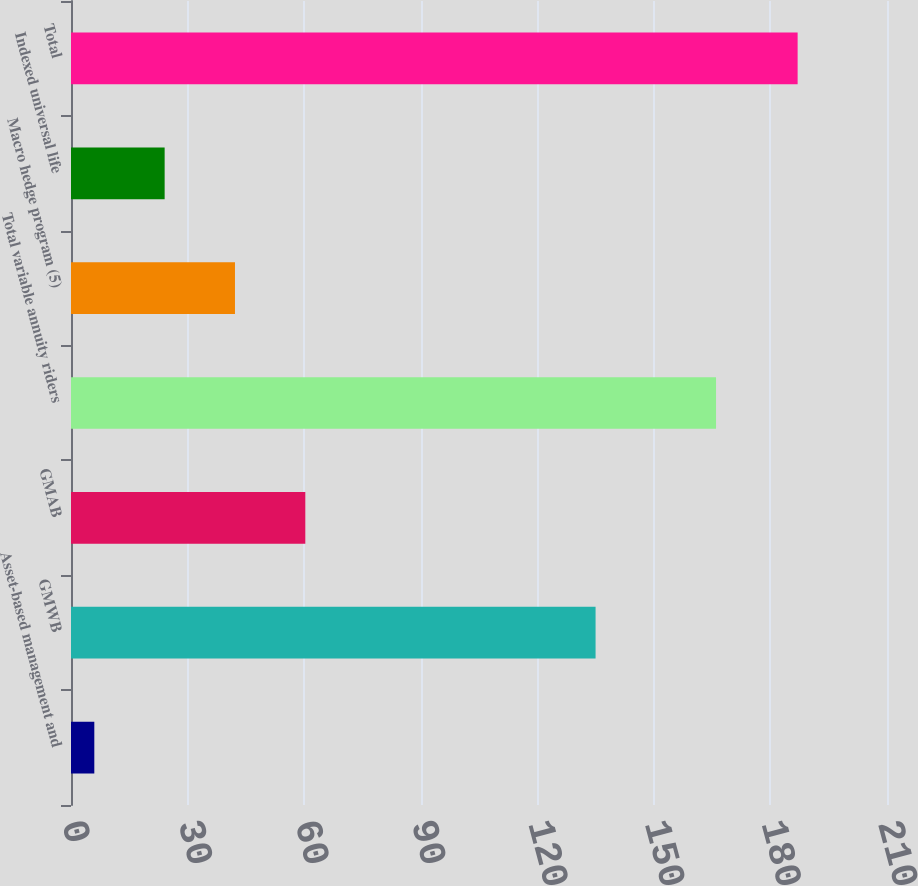<chart> <loc_0><loc_0><loc_500><loc_500><bar_chart><fcel>Asset-based management and<fcel>GMWB<fcel>GMAB<fcel>Total variable annuity riders<fcel>Macro hedge program (5)<fcel>Indexed universal life<fcel>Total<nl><fcel>6<fcel>135<fcel>60.3<fcel>166<fcel>42.2<fcel>24.1<fcel>187<nl></chart> 